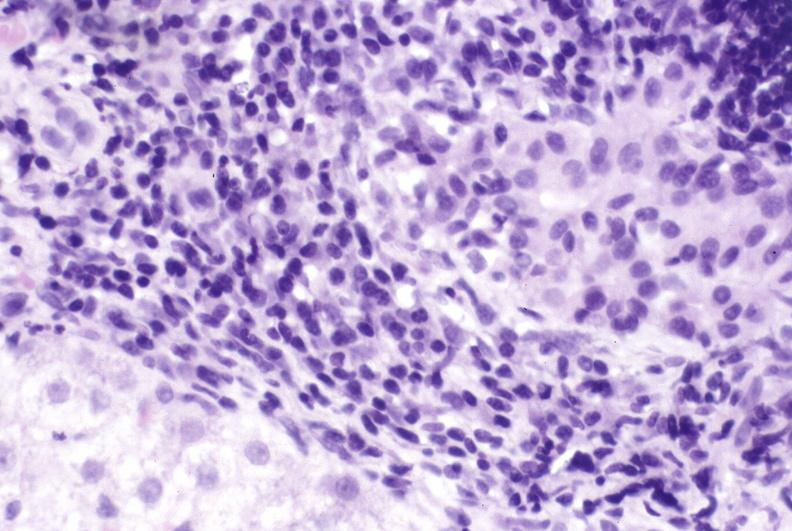does atheromatous embolus show primary biliary cirrhosis?
Answer the question using a single word or phrase. No 